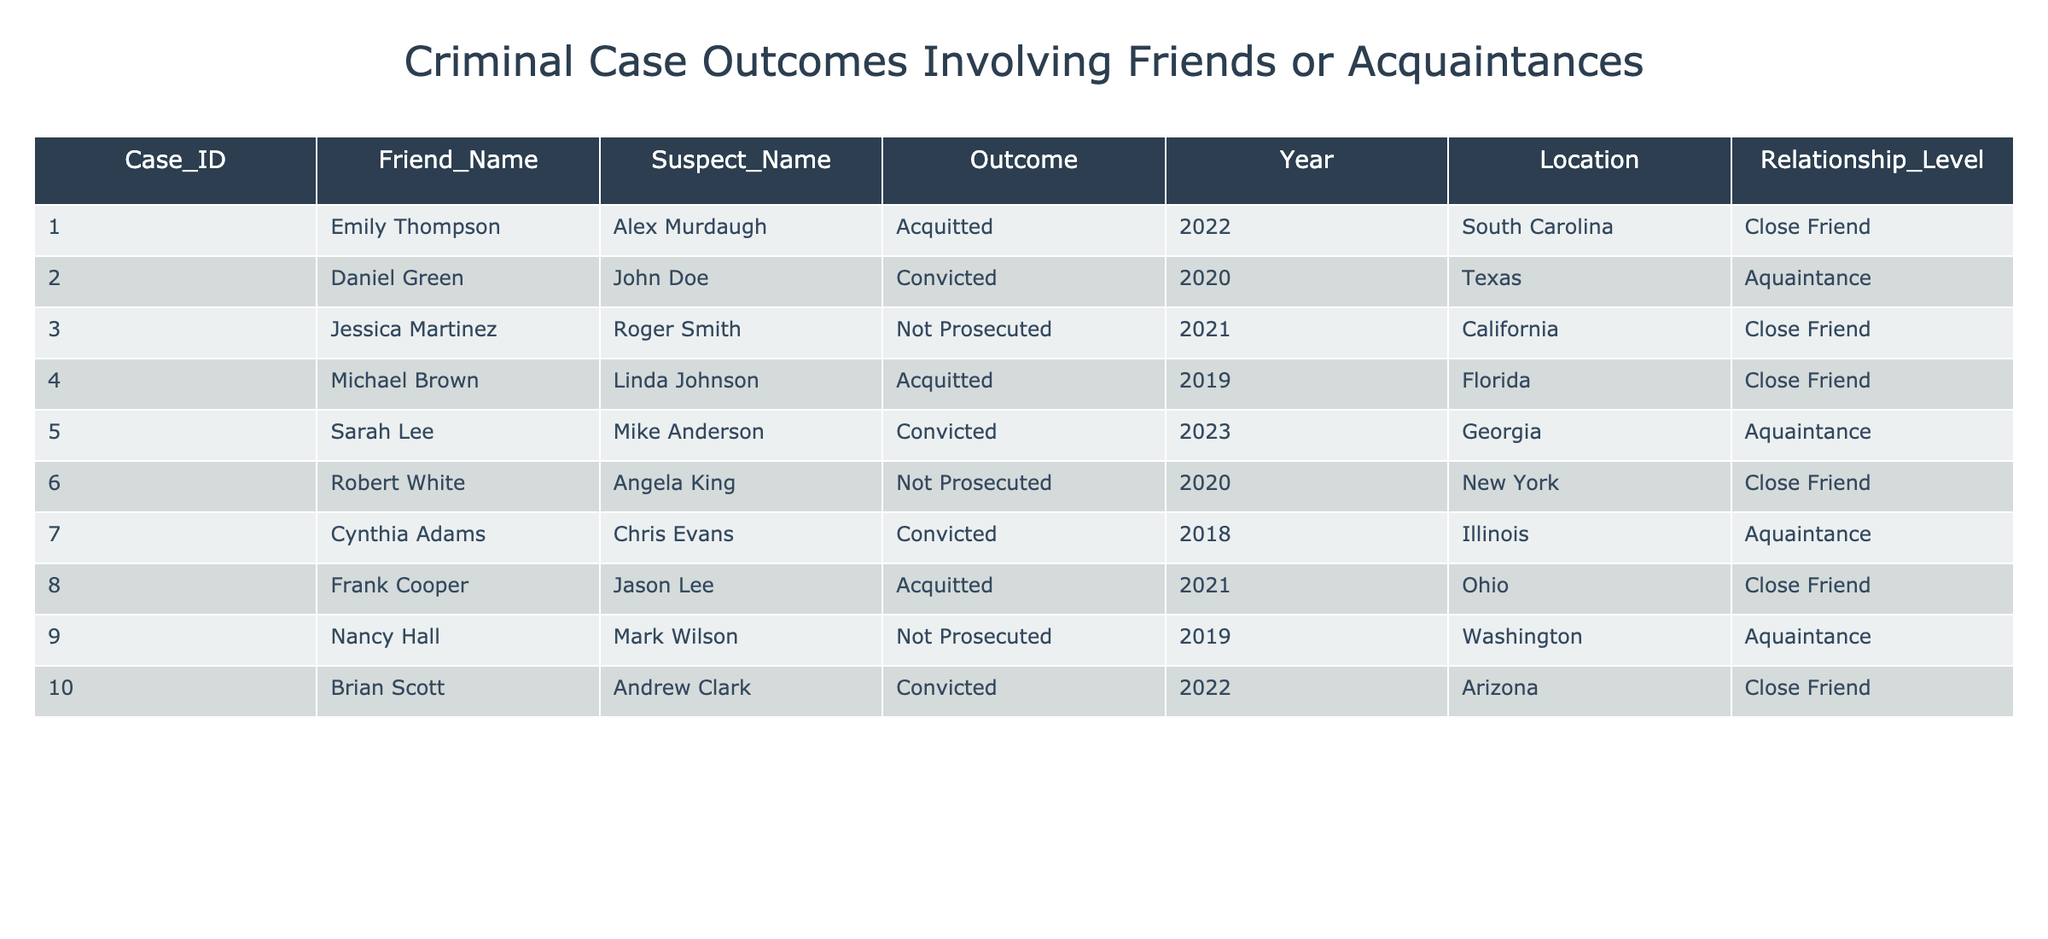What is the total number of cases involving friends or acquaintances of suspects? There are 10 entries in the table representing different cases involving friends or acquaintances of suspects.
Answer: 10 How many cases resulted in a conviction? Looking through the 'Outcome' column, three cases (Case_IDs 2, 5, and 7) are marked as 'Convicted', so the total is 3.
Answer: 3 Which friend is associated with the suspect Alex Murdaugh? Referring to the table, Emily Thompson is listed as the friend associated with Alex Murdaugh under Case_ID 1.
Answer: Emily Thompson Was there any friend of a suspect who was not prosecuted? Yes, the table indicates there are three cases (Case_IDs 3, 6, and 9) where friends were not prosecuted.
Answer: Yes What is the average outcome for close friends in this table? Analyzing the 'Outcome' for close friends, there are four close friend cases: 1 Acquitted, 1 Not Prosecuted, and 2 Convicted. The outcomes are: Acquitted (0), Not Prosecuted (0.5), and Convicted (1) = (0 + 0.5 + 2) / 4 = 0.625. The average can be contextualized as tending towards Convicted but remains a mixed outcome leaning neutral.
Answer: 0.625 How many friends had a close relationship with suspects who were acquitted? In the Outcome column, two cases (Case_IDs 1 and 4) with friends related to suspects resulted in acquittals. Both cases have 'Close Friend' in the Relationship_Level column.
Answer: 2 Which friend had the highest probability of conviction based on their relationship level? Evaluating friends, we see they mostly fall into two categories: Close Friends and Acquaintances. There are six cases with Acquaintances (3 Convicted; therefore, the probability per acquaintance is 3/6 = 0.5), and four cases with Close Friends (2 Convicted; therefore, 2/4 = 0.5). Since both categories show equal outcomes, there’s no definitive friend with higher odds of conviction based solely on their relation type.
Answer: Equally likely What percentage of friends involved in cases were convicted? There are 3 convictions out of 10 total cases. To find the percentage, (3/10) * 100%. Thus, calculating further gives us 30%.
Answer: 30% Which state had the most cases involving friends or acquaintances of suspects? A query of the 'Location' column shows South Carolina (1 case), Texas (1), California (1), Florida (1), Georgia (1), New York (1), Illinois (1), Ohio (1), Washington (1), and Arizona (1)—each with just one occurrence. Thus, there are no states with a higher representation.
Answer: All states have equal representation 